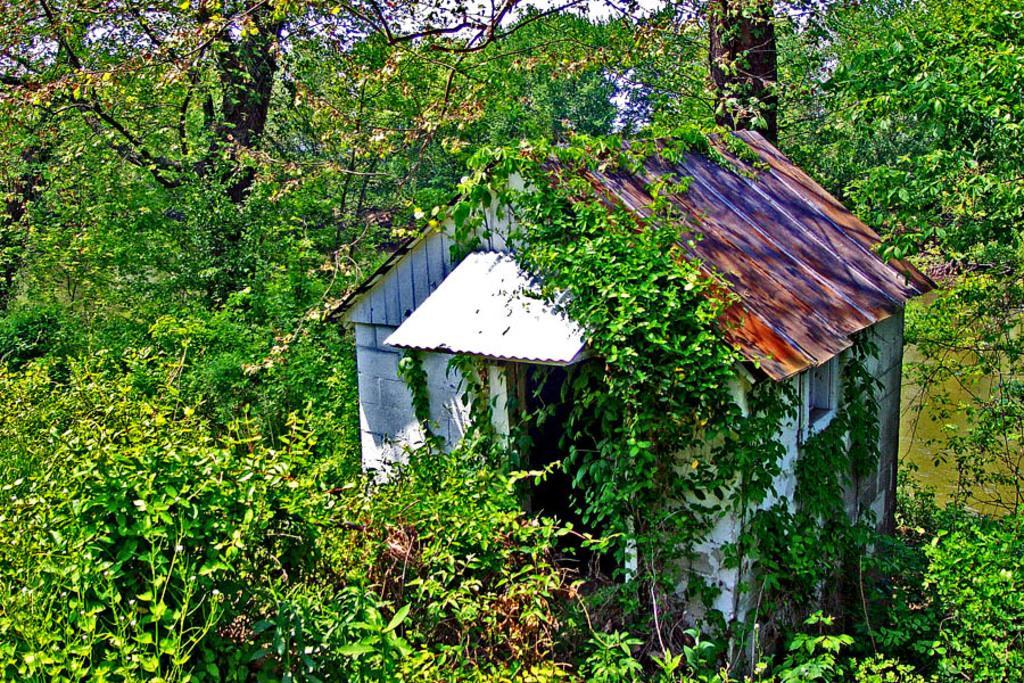Please provide a concise description of this image. This picture shows a house with trees around. 